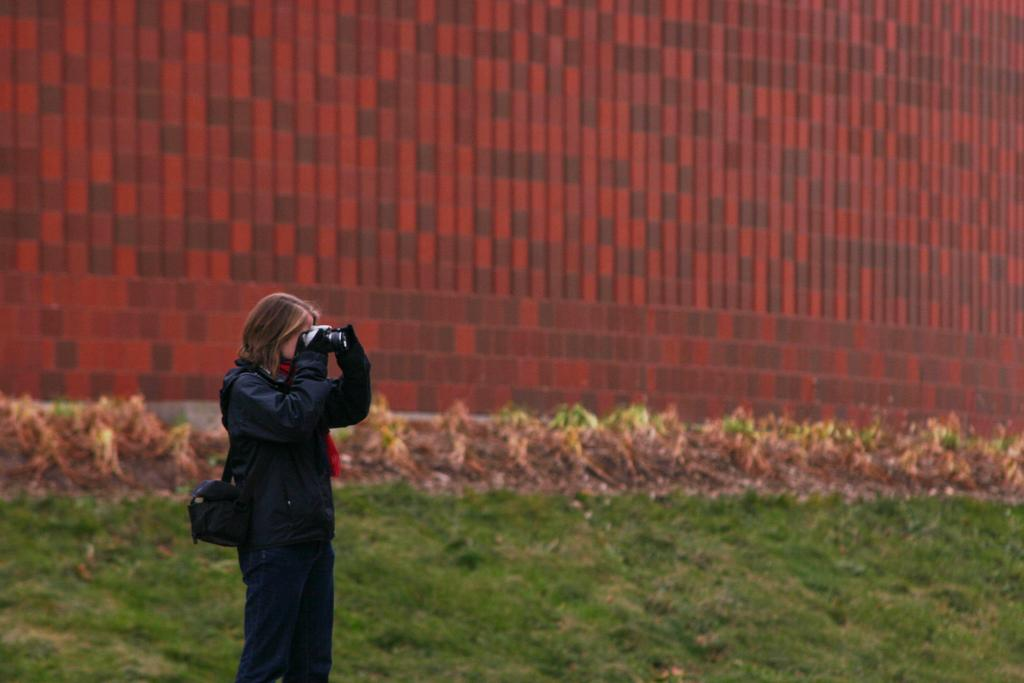What is the woman doing in the image? The woman is standing on grassy land. What is the woman holding in the image? The woman is holding a camera. Where is the camera positioned in the image? The camera is at the bottom of the image. What can be seen in the background of the image? There is a wall in the background of the image. How many minutes does the woman spend taking pictures of the trucks in the image? There are no trucks present in the image, so the woman cannot be taking pictures of them. 